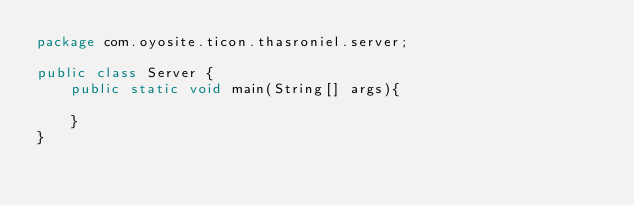Convert code to text. <code><loc_0><loc_0><loc_500><loc_500><_Java_>package com.oyosite.ticon.thasroniel.server;

public class Server {
    public static void main(String[] args){

    }
}
</code> 